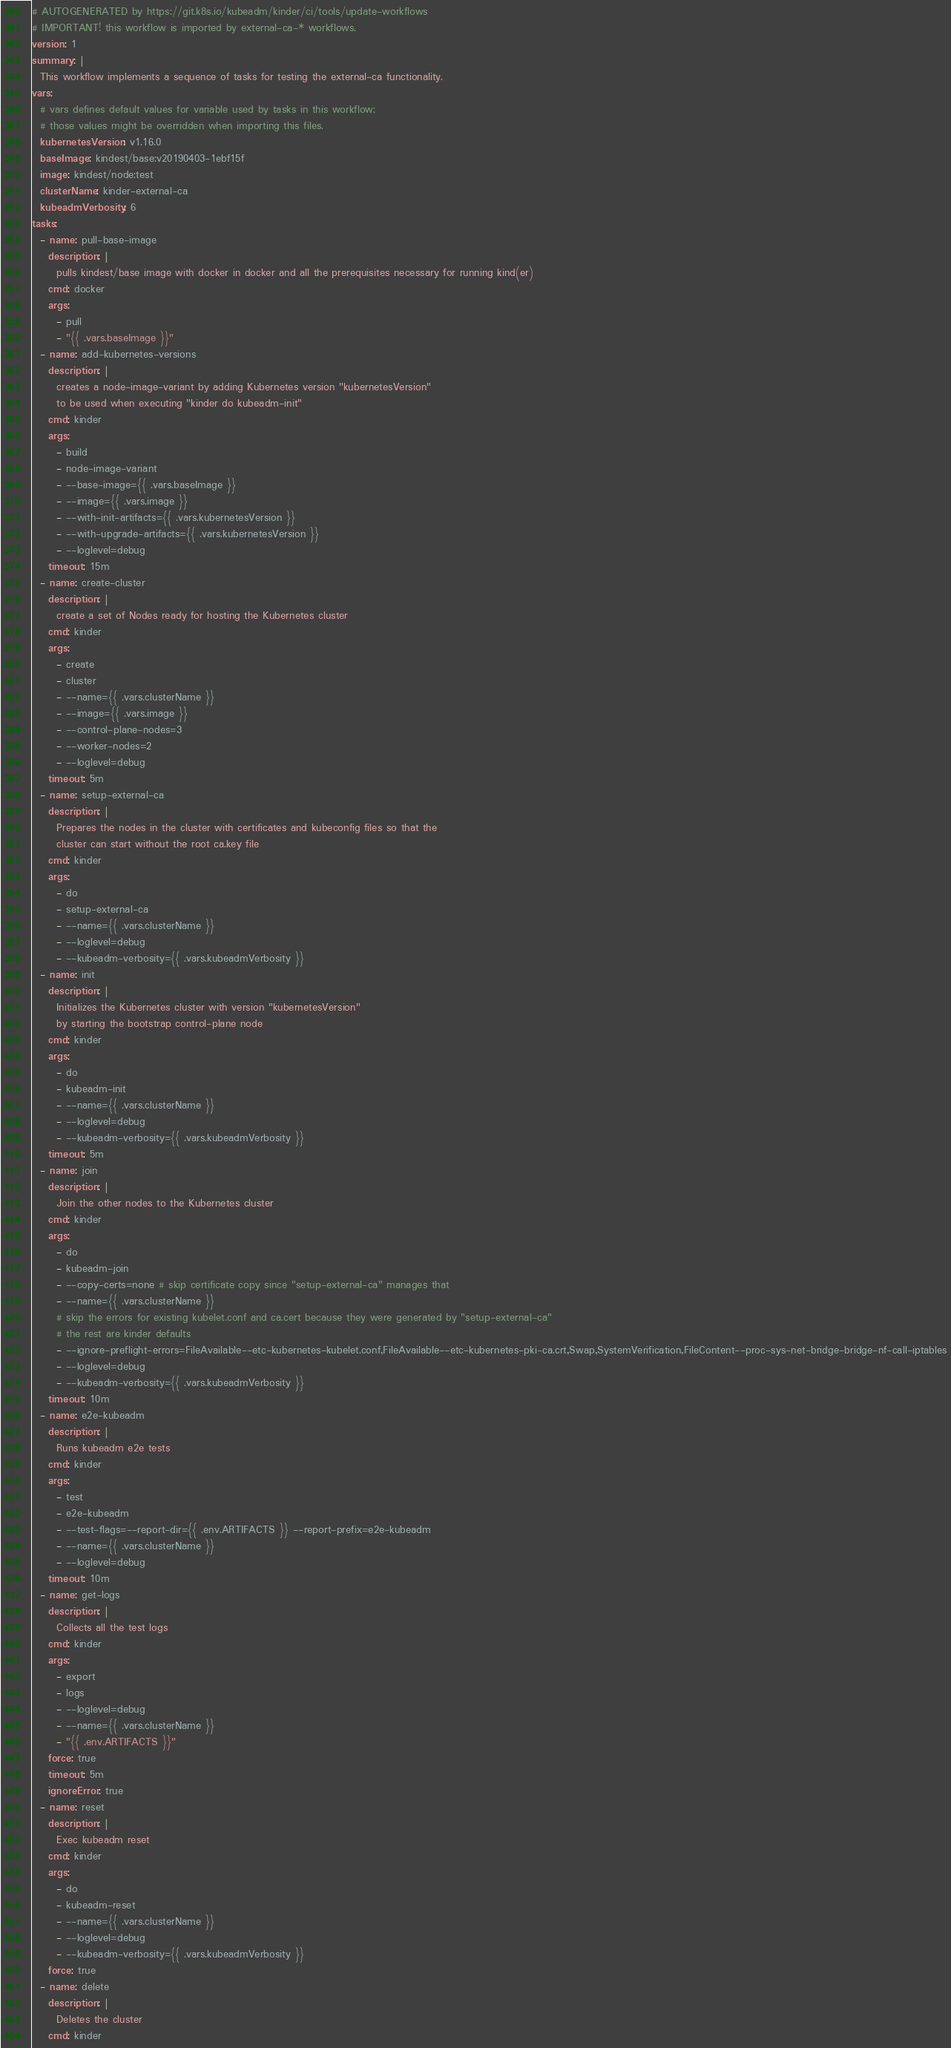Convert code to text. <code><loc_0><loc_0><loc_500><loc_500><_YAML_># AUTOGENERATED by https://git.k8s.io/kubeadm/kinder/ci/tools/update-workflows
# IMPORTANT! this workflow is imported by external-ca-* workflows.
version: 1
summary: |
  This workflow implements a sequence of tasks for testing the external-ca functionality.
vars:
  # vars defines default values for variable used by tasks in this workflow;
  # those values might be overridden when importing this files.
  kubernetesVersion: v1.16.0
  baseImage: kindest/base:v20190403-1ebf15f
  image: kindest/node:test
  clusterName: kinder-external-ca
  kubeadmVerbosity: 6
tasks:
  - name: pull-base-image
    description: |
      pulls kindest/base image with docker in docker and all the prerequisites necessary for running kind(er)
    cmd: docker
    args:
      - pull
      - "{{ .vars.baseImage }}"
  - name: add-kubernetes-versions
    description: |
      creates a node-image-variant by adding Kubernetes version "kubernetesVersion"
      to be used when executing "kinder do kubeadm-init"
    cmd: kinder
    args:
      - build
      - node-image-variant
      - --base-image={{ .vars.baseImage }}
      - --image={{ .vars.image }}
      - --with-init-artifacts={{ .vars.kubernetesVersion }}
      - --with-upgrade-artifacts={{ .vars.kubernetesVersion }}
      - --loglevel=debug
    timeout: 15m
  - name: create-cluster
    description: |
      create a set of Nodes ready for hosting the Kubernetes cluster
    cmd: kinder
    args:
      - create
      - cluster
      - --name={{ .vars.clusterName }}
      - --image={{ .vars.image }}
      - --control-plane-nodes=3
      - --worker-nodes=2
      - --loglevel=debug
    timeout: 5m
  - name: setup-external-ca
    description: |
      Prepares the nodes in the cluster with certificates and kubeconfig files so that the
      cluster can start without the root ca.key file
    cmd: kinder
    args:
      - do
      - setup-external-ca
      - --name={{ .vars.clusterName }}
      - --loglevel=debug
      - --kubeadm-verbosity={{ .vars.kubeadmVerbosity }}
  - name: init
    description: |
      Initializes the Kubernetes cluster with version "kubernetesVersion"
      by starting the bootstrap control-plane node
    cmd: kinder
    args:
      - do
      - kubeadm-init
      - --name={{ .vars.clusterName }}
      - --loglevel=debug
      - --kubeadm-verbosity={{ .vars.kubeadmVerbosity }}
    timeout: 5m
  - name: join
    description: |
      Join the other nodes to the Kubernetes cluster
    cmd: kinder
    args:
      - do
      - kubeadm-join
      - --copy-certs=none # skip certificate copy since "setup-external-ca" manages that
      - --name={{ .vars.clusterName }}
      # skip the errors for existing kubelet.conf and ca.cert because they were generated by "setup-external-ca"
      # the rest are kinder defaults
      - --ignore-preflight-errors=FileAvailable--etc-kubernetes-kubelet.conf,FileAvailable--etc-kubernetes-pki-ca.crt,Swap,SystemVerification,FileContent--proc-sys-net-bridge-bridge-nf-call-iptables
      - --loglevel=debug
      - --kubeadm-verbosity={{ .vars.kubeadmVerbosity }}
    timeout: 10m
  - name: e2e-kubeadm
    description: |
      Runs kubeadm e2e tests
    cmd: kinder
    args:
      - test
      - e2e-kubeadm
      - --test-flags=--report-dir={{ .env.ARTIFACTS }} --report-prefix=e2e-kubeadm
      - --name={{ .vars.clusterName }}
      - --loglevel=debug
    timeout: 10m
  - name: get-logs
    description: |
      Collects all the test logs
    cmd: kinder
    args:
      - export
      - logs
      - --loglevel=debug
      - --name={{ .vars.clusterName }}
      - "{{ .env.ARTIFACTS }}"
    force: true
    timeout: 5m
    ignoreError: true
  - name: reset
    description: |
      Exec kubeadm reset
    cmd: kinder
    args:
      - do
      - kubeadm-reset
      - --name={{ .vars.clusterName }}
      - --loglevel=debug
      - --kubeadm-verbosity={{ .vars.kubeadmVerbosity }}
    force: true
  - name: delete
    description: |
      Deletes the cluster
    cmd: kinder</code> 